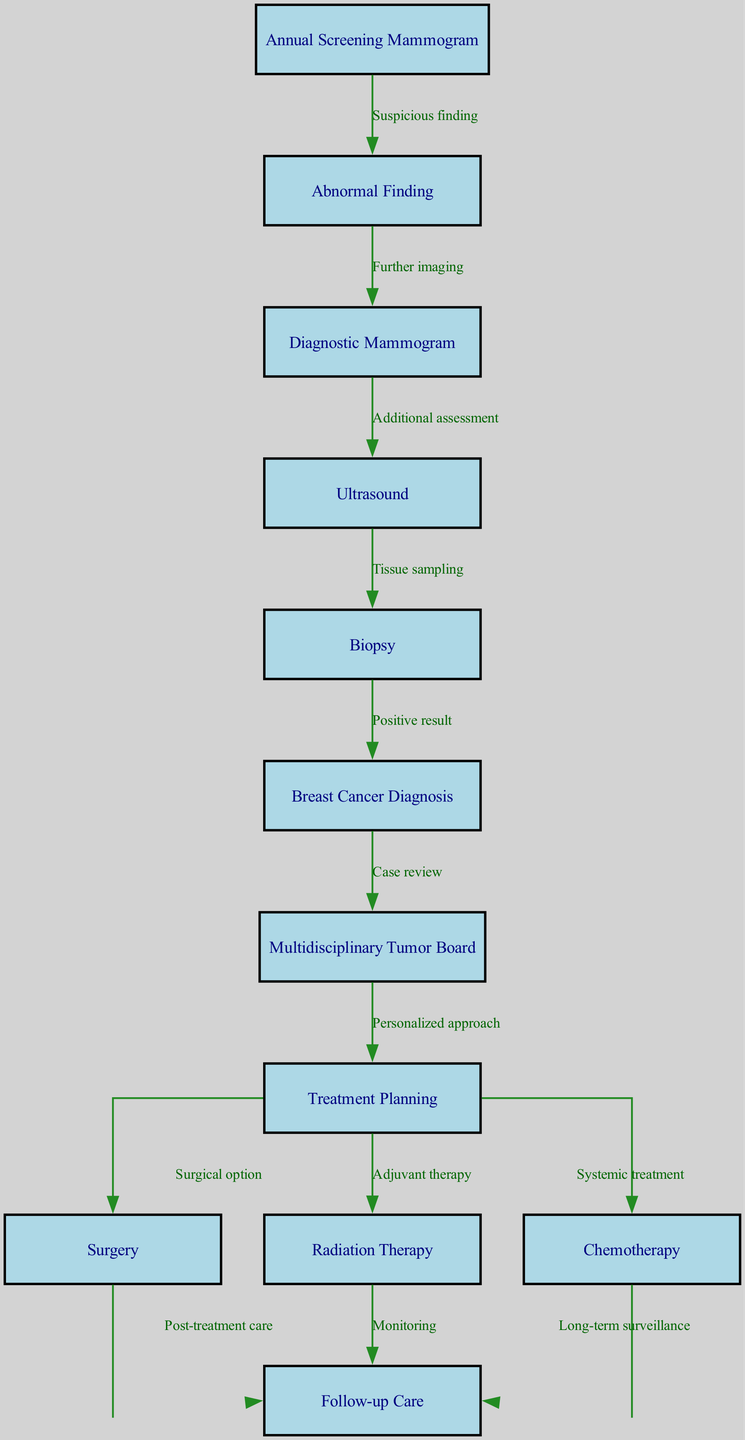What is the first step in the clinical pathway? The first step in the clinical pathway is represented by node 1, which is "Annual Screening Mammogram."
Answer: Annual Screening Mammogram How many nodes are in the diagram? By counting the distinct nodes listed in the data, there are a total of 12 nodes present.
Answer: 12 What occurs after an abnormal finding during screening? The diagram indicates that after an abnormal finding, a "Diagnostic Mammogram" is performed, represented by moving from node 2 to node 3.
Answer: Diagnostic Mammogram What is one of the treatment options following the treatment planning? The diagram shows that after treatment planning, options include "Surgery," "Radiation Therapy," and "Chemotherapy," represented by the edges from node 8.
Answer: Surgery What connects the "Biopsy" to "Breast Cancer Diagnosis"? The connection from "Biopsy" (node 5) to "Breast Cancer Diagnosis" (node 6) is represented by the edge labeled "Positive result."
Answer: Positive result What type of care follows surgical treatment? Following surgical treatment, the next node is "Follow-up Care" (node 12), which indicates the type of care post-surgery.
Answer: Follow-up Care What diagram type is used to illustrate breast cancer screening, diagnosis, and treatment? The diagram is a "Clinical Pathway," which is specific to the processes and steps involved in patient care for breast cancer.
Answer: Clinical Pathway What is reviewed by the Multidisciplinary Tumor Board? The Multidisciplinary Tumor Board reviews the "Breast Cancer Diagnosis," which is the case presented by the previous node 6.
Answer: Breast Cancer Diagnosis What is the final step in the clinical pathway? The final step in the clinical pathway is the "Follow-up Care," which comes after all treatment options have been explored and implemented.
Answer: Follow-up Care 